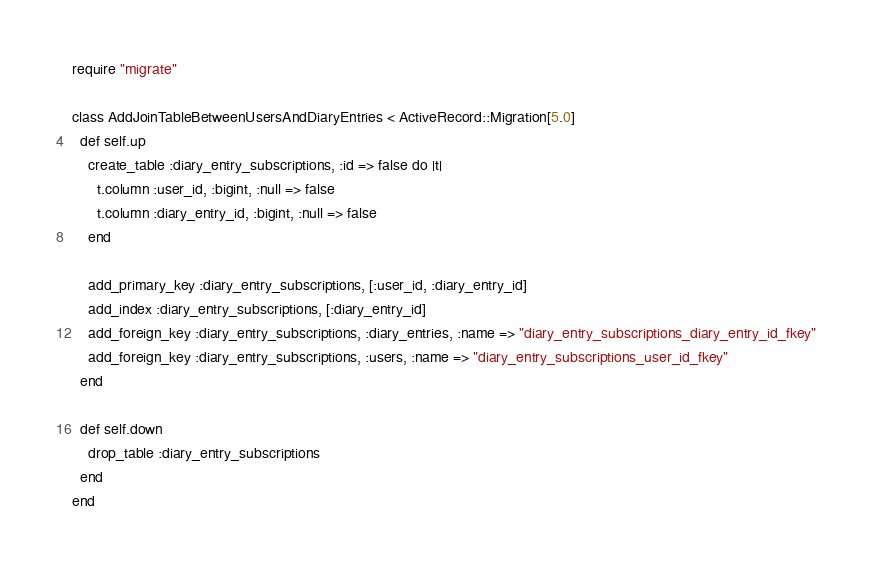Convert code to text. <code><loc_0><loc_0><loc_500><loc_500><_Ruby_>require "migrate"

class AddJoinTableBetweenUsersAndDiaryEntries < ActiveRecord::Migration[5.0]
  def self.up
    create_table :diary_entry_subscriptions, :id => false do |t|
      t.column :user_id, :bigint, :null => false
      t.column :diary_entry_id, :bigint, :null => false
    end

    add_primary_key :diary_entry_subscriptions, [:user_id, :diary_entry_id]
    add_index :diary_entry_subscriptions, [:diary_entry_id]
    add_foreign_key :diary_entry_subscriptions, :diary_entries, :name => "diary_entry_subscriptions_diary_entry_id_fkey"
    add_foreign_key :diary_entry_subscriptions, :users, :name => "diary_entry_subscriptions_user_id_fkey"
  end

  def self.down
    drop_table :diary_entry_subscriptions
  end
end
</code> 